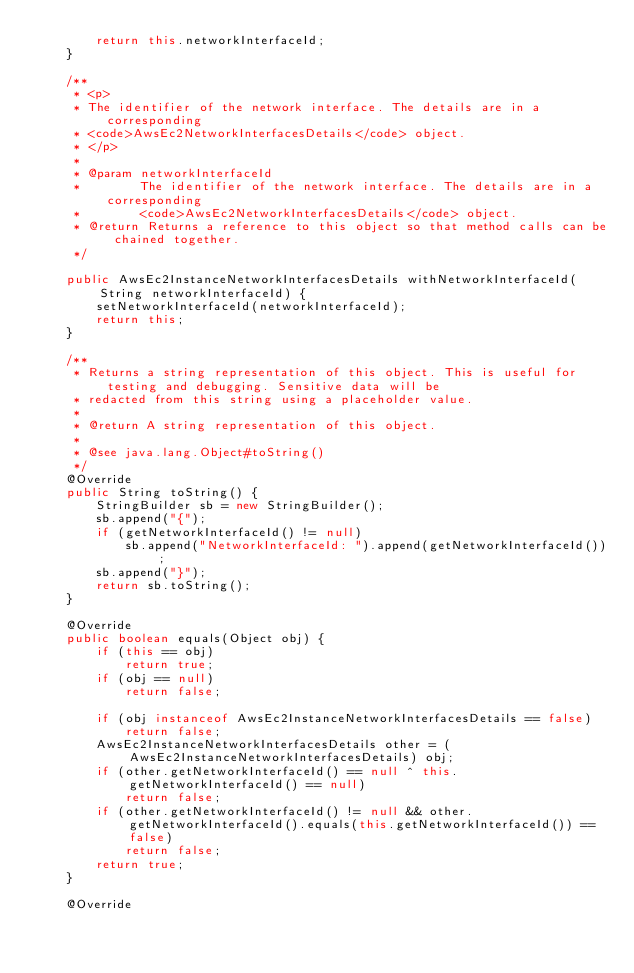Convert code to text. <code><loc_0><loc_0><loc_500><loc_500><_Java_>        return this.networkInterfaceId;
    }

    /**
     * <p>
     * The identifier of the network interface. The details are in a corresponding
     * <code>AwsEc2NetworkInterfacesDetails</code> object.
     * </p>
     * 
     * @param networkInterfaceId
     *        The identifier of the network interface. The details are in a corresponding
     *        <code>AwsEc2NetworkInterfacesDetails</code> object.
     * @return Returns a reference to this object so that method calls can be chained together.
     */

    public AwsEc2InstanceNetworkInterfacesDetails withNetworkInterfaceId(String networkInterfaceId) {
        setNetworkInterfaceId(networkInterfaceId);
        return this;
    }

    /**
     * Returns a string representation of this object. This is useful for testing and debugging. Sensitive data will be
     * redacted from this string using a placeholder value.
     *
     * @return A string representation of this object.
     *
     * @see java.lang.Object#toString()
     */
    @Override
    public String toString() {
        StringBuilder sb = new StringBuilder();
        sb.append("{");
        if (getNetworkInterfaceId() != null)
            sb.append("NetworkInterfaceId: ").append(getNetworkInterfaceId());
        sb.append("}");
        return sb.toString();
    }

    @Override
    public boolean equals(Object obj) {
        if (this == obj)
            return true;
        if (obj == null)
            return false;

        if (obj instanceof AwsEc2InstanceNetworkInterfacesDetails == false)
            return false;
        AwsEc2InstanceNetworkInterfacesDetails other = (AwsEc2InstanceNetworkInterfacesDetails) obj;
        if (other.getNetworkInterfaceId() == null ^ this.getNetworkInterfaceId() == null)
            return false;
        if (other.getNetworkInterfaceId() != null && other.getNetworkInterfaceId().equals(this.getNetworkInterfaceId()) == false)
            return false;
        return true;
    }

    @Override</code> 